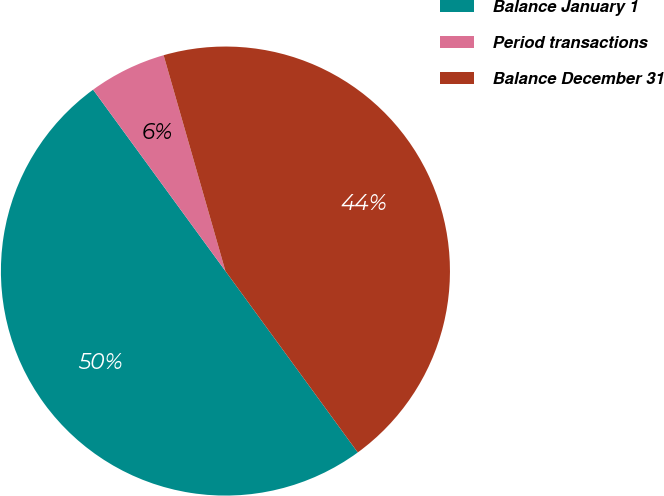Convert chart. <chart><loc_0><loc_0><loc_500><loc_500><pie_chart><fcel>Balance January 1<fcel>Period transactions<fcel>Balance December 31<nl><fcel>50.0%<fcel>5.59%<fcel>44.41%<nl></chart> 